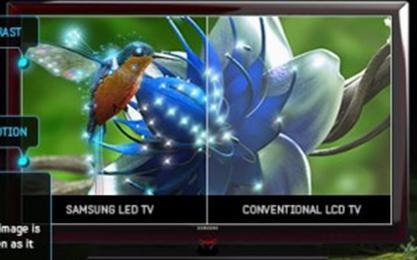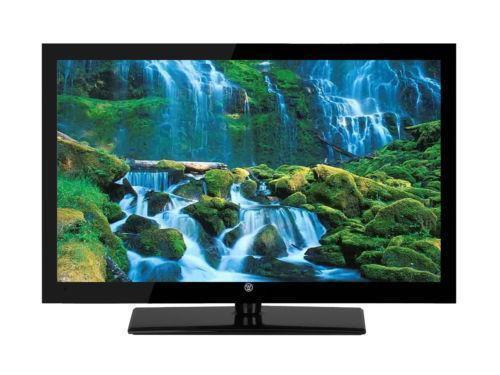The first image is the image on the left, the second image is the image on the right. For the images displayed, is the sentence "In at least one image there is a television with a blue flower and a single hummingbird drinking from it." factually correct? Answer yes or no. Yes. The first image is the image on the left, the second image is the image on the right. Considering the images on both sides, is "One of the images features a television displaying a hummingbird next to a flower." valid? Answer yes or no. Yes. 